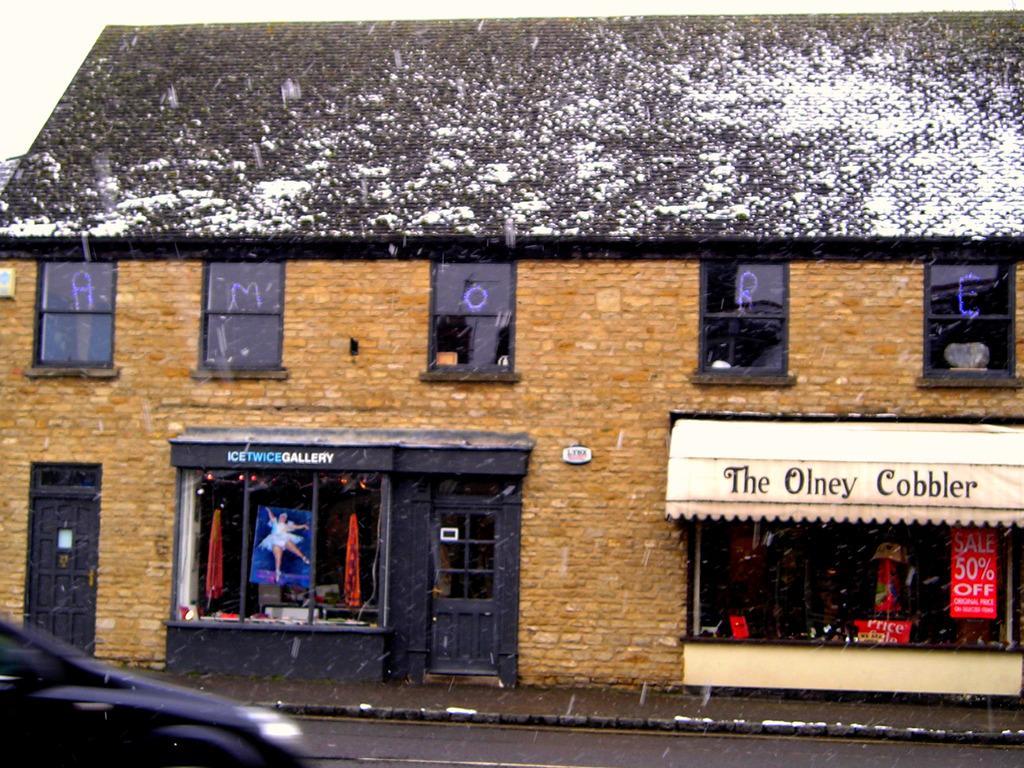Please provide a concise description of this image. There is a restaurant presenting in this picture. There is a vehicle in the bottom left of the image. 